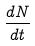Convert formula to latex. <formula><loc_0><loc_0><loc_500><loc_500>\frac { d N } { d t }</formula> 